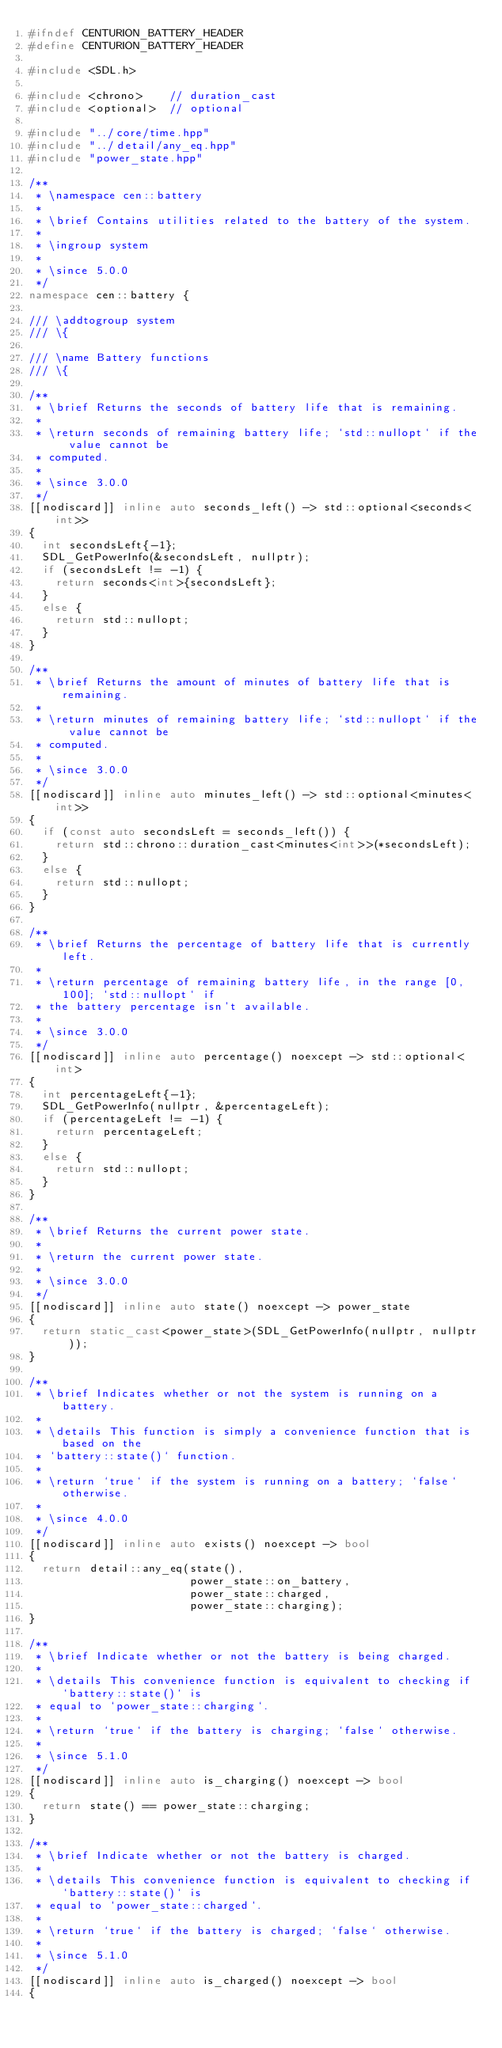Convert code to text. <code><loc_0><loc_0><loc_500><loc_500><_C++_>#ifndef CENTURION_BATTERY_HEADER
#define CENTURION_BATTERY_HEADER

#include <SDL.h>

#include <chrono>    // duration_cast
#include <optional>  // optional

#include "../core/time.hpp"
#include "../detail/any_eq.hpp"
#include "power_state.hpp"

/**
 * \namespace cen::battery
 *
 * \brief Contains utilities related to the battery of the system.
 *
 * \ingroup system
 *
 * \since 5.0.0
 */
namespace cen::battery {

/// \addtogroup system
/// \{

/// \name Battery functions
/// \{

/**
 * \brief Returns the seconds of battery life that is remaining.
 *
 * \return seconds of remaining battery life; `std::nullopt` if the value cannot be
 * computed.
 *
 * \since 3.0.0
 */
[[nodiscard]] inline auto seconds_left() -> std::optional<seconds<int>>
{
  int secondsLeft{-1};
  SDL_GetPowerInfo(&secondsLeft, nullptr);
  if (secondsLeft != -1) {
    return seconds<int>{secondsLeft};
  }
  else {
    return std::nullopt;
  }
}

/**
 * \brief Returns the amount of minutes of battery life that is remaining.
 *
 * \return minutes of remaining battery life; `std::nullopt` if the value cannot be
 * computed.
 *
 * \since 3.0.0
 */
[[nodiscard]] inline auto minutes_left() -> std::optional<minutes<int>>
{
  if (const auto secondsLeft = seconds_left()) {
    return std::chrono::duration_cast<minutes<int>>(*secondsLeft);
  }
  else {
    return std::nullopt;
  }
}

/**
 * \brief Returns the percentage of battery life that is currently left.
 *
 * \return percentage of remaining battery life, in the range [0, 100]; `std::nullopt` if
 * the battery percentage isn't available.
 *
 * \since 3.0.0
 */
[[nodiscard]] inline auto percentage() noexcept -> std::optional<int>
{
  int percentageLeft{-1};
  SDL_GetPowerInfo(nullptr, &percentageLeft);
  if (percentageLeft != -1) {
    return percentageLeft;
  }
  else {
    return std::nullopt;
  }
}

/**
 * \brief Returns the current power state.
 *
 * \return the current power state.
 *
 * \since 3.0.0
 */
[[nodiscard]] inline auto state() noexcept -> power_state
{
  return static_cast<power_state>(SDL_GetPowerInfo(nullptr, nullptr));
}

/**
 * \brief Indicates whether or not the system is running on a battery.
 *
 * \details This function is simply a convenience function that is based on the
 * `battery::state()` function.
 *
 * \return `true` if the system is running on a battery; `false` otherwise.
 *
 * \since 4.0.0
 */
[[nodiscard]] inline auto exists() noexcept -> bool
{
  return detail::any_eq(state(),
                        power_state::on_battery,
                        power_state::charged,
                        power_state::charging);
}

/**
 * \brief Indicate whether or not the battery is being charged.
 *
 * \details This convenience function is equivalent to checking if `battery::state()` is
 * equal to `power_state::charging`.
 *
 * \return `true` if the battery is charging; `false` otherwise.
 *
 * \since 5.1.0
 */
[[nodiscard]] inline auto is_charging() noexcept -> bool
{
  return state() == power_state::charging;
}

/**
 * \brief Indicate whether or not the battery is charged.
 *
 * \details This convenience function is equivalent to checking if `battery::state()` is
 * equal to `power_state::charged`.
 *
 * \return `true` if the battery is charged; `false` otherwise.
 *
 * \since 5.1.0
 */
[[nodiscard]] inline auto is_charged() noexcept -> bool
{</code> 